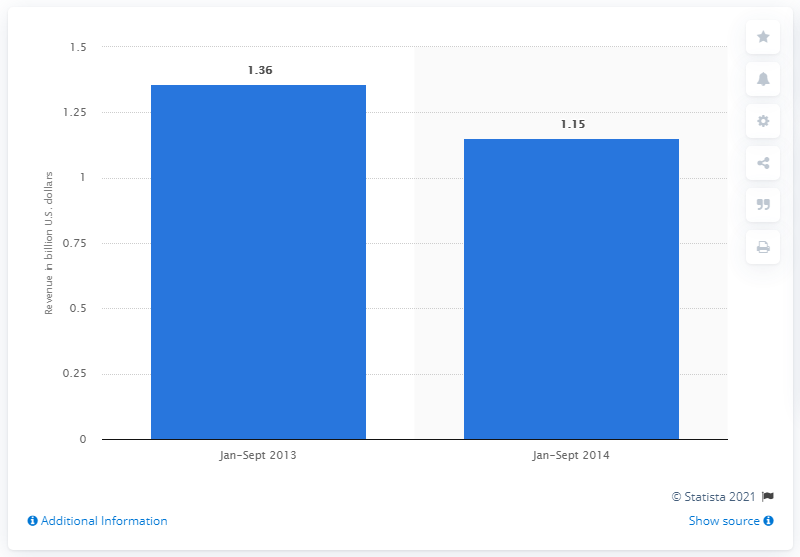Identify some key points in this picture. In the first nine months of 2014, Weight Watchers reached a revenue of 1.15 billion USD. 